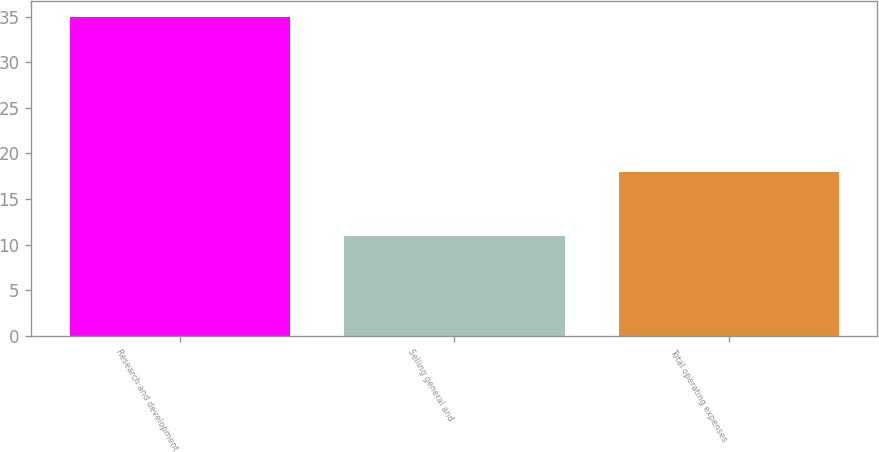<chart> <loc_0><loc_0><loc_500><loc_500><bar_chart><fcel>Research and development<fcel>Selling general and<fcel>Total operating expenses<nl><fcel>35<fcel>11<fcel>18<nl></chart> 